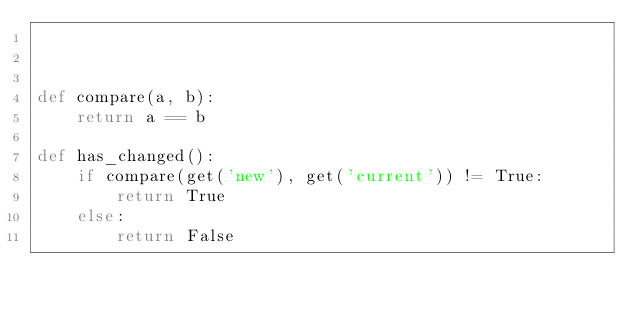<code> <loc_0><loc_0><loc_500><loc_500><_Python_>


def compare(a, b):
    return a == b

def has_changed():
    if compare(get('new'), get('current')) != True:
        return True
    else:
        return False
</code> 